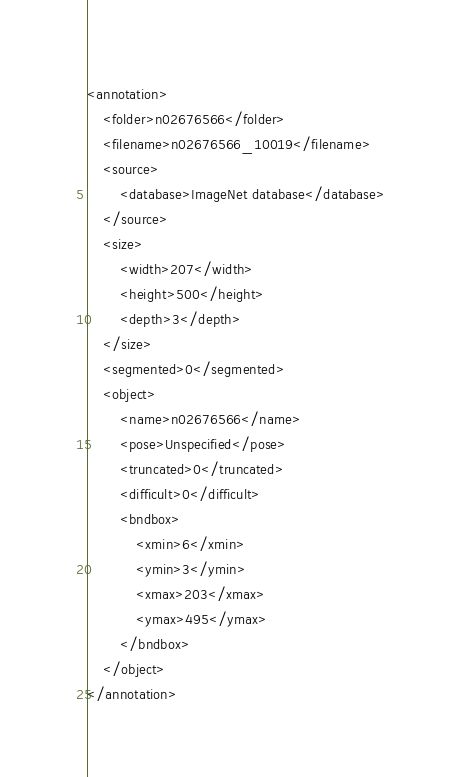<code> <loc_0><loc_0><loc_500><loc_500><_XML_><annotation>
	<folder>n02676566</folder>
	<filename>n02676566_10019</filename>
	<source>
		<database>ImageNet database</database>
	</source>
	<size>
		<width>207</width>
		<height>500</height>
		<depth>3</depth>
	</size>
	<segmented>0</segmented>
	<object>
		<name>n02676566</name>
		<pose>Unspecified</pose>
		<truncated>0</truncated>
		<difficult>0</difficult>
		<bndbox>
			<xmin>6</xmin>
			<ymin>3</ymin>
			<xmax>203</xmax>
			<ymax>495</ymax>
		</bndbox>
	</object>
</annotation></code> 